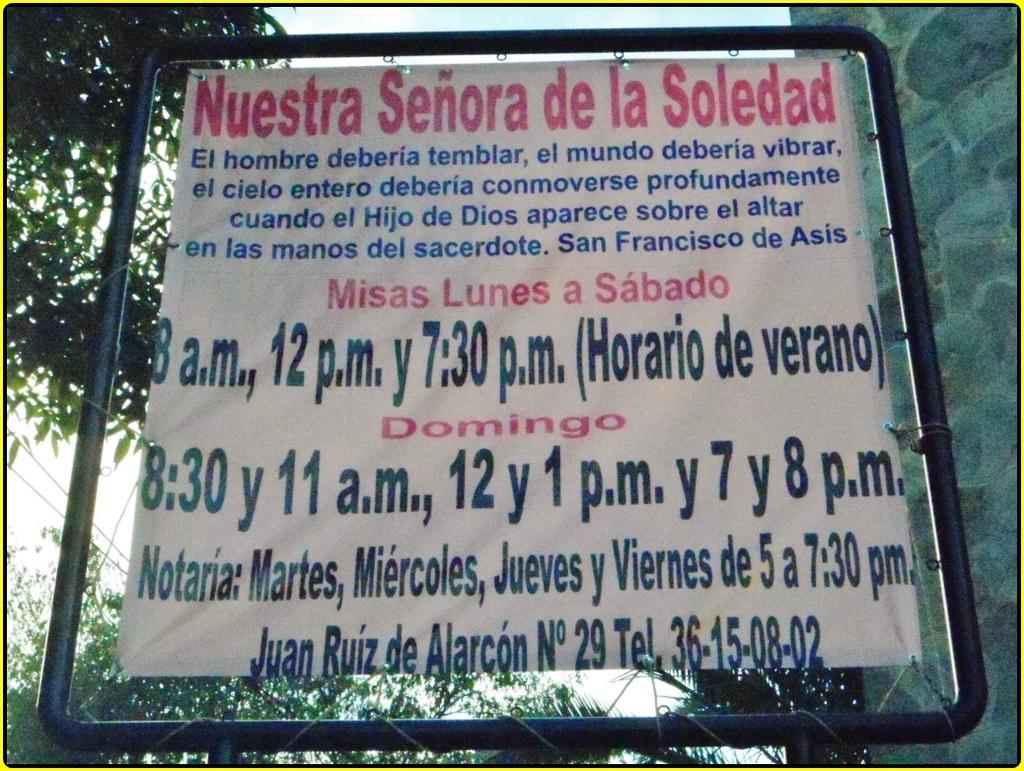What is the main subject in the center of the image? There is a banner in the center of the image. What can be seen on the right side of the image? There is a wall on the right side of the image. What type of natural elements are visible in the background of the image? There are trees and the sky visible in the background of the image. How many bikes are parked in front of the wall in the image? There are no bikes present in the image. What type of comb is being used to style the trees in the background? There is no comb present in the image, and the trees are not being styled. 